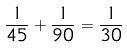<formula> <loc_0><loc_0><loc_500><loc_500>\frac { 1 } { 4 5 } + \frac { 1 } { 9 0 } = \frac { 1 } { 3 0 }</formula> 